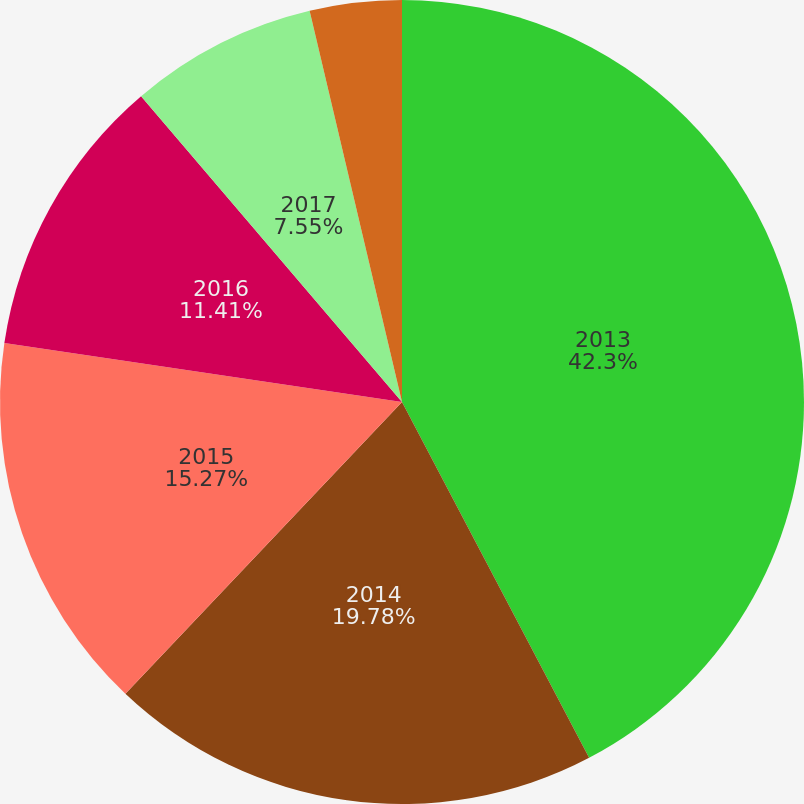Convert chart. <chart><loc_0><loc_0><loc_500><loc_500><pie_chart><fcel>2013<fcel>2014<fcel>2015<fcel>2016<fcel>2017<fcel>Thereafter<nl><fcel>42.29%<fcel>19.78%<fcel>15.27%<fcel>11.41%<fcel>7.55%<fcel>3.69%<nl></chart> 